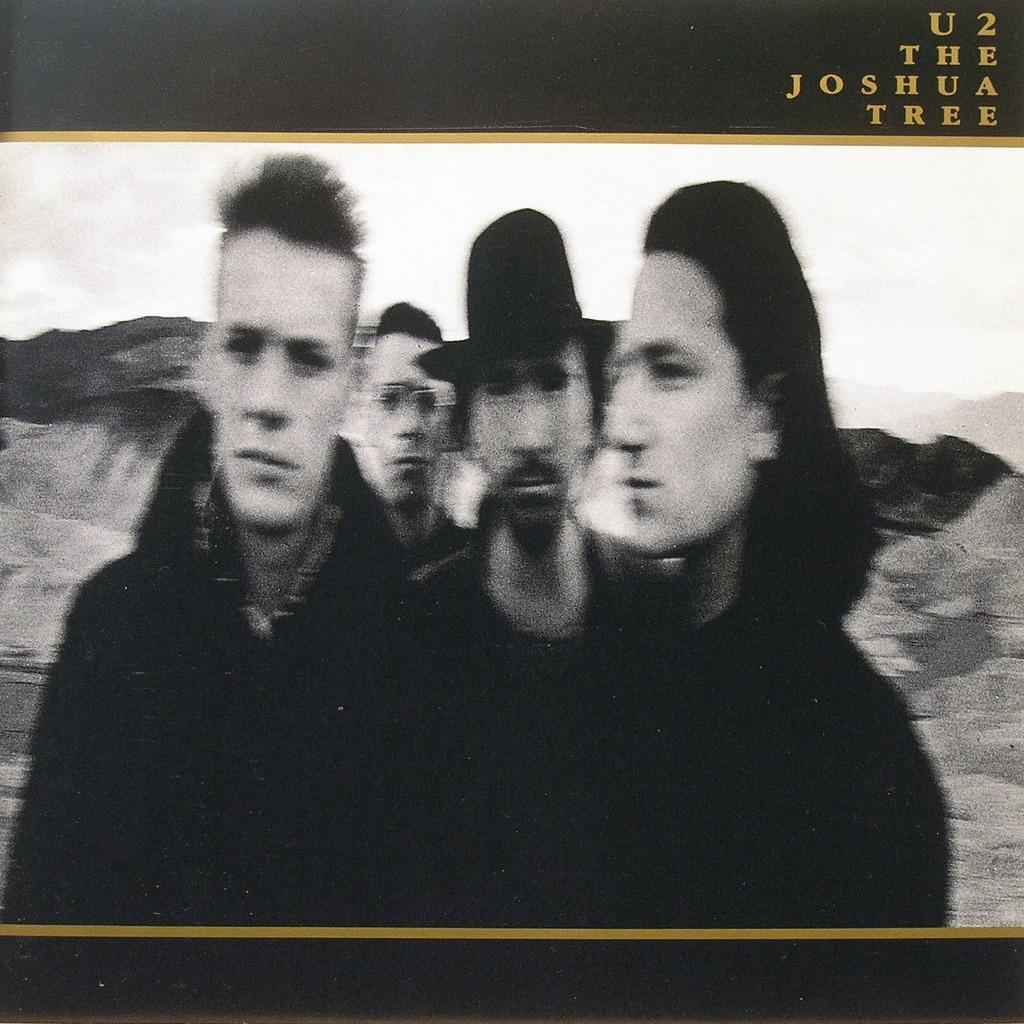Can you describe this image briefly? It is the black and white image in which we can see there are four men in the middle. On the right side top there is some text. 